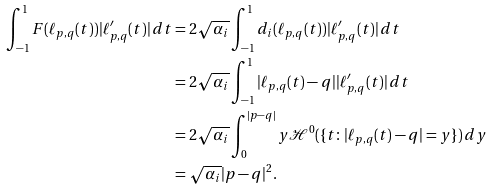Convert formula to latex. <formula><loc_0><loc_0><loc_500><loc_500>\int _ { - 1 } ^ { 1 } F ( \ell _ { p , q } ( t ) ) | \ell _ { p , q } ^ { \prime } ( t ) | \, d t & = 2 \sqrt { \alpha _ { i } } \int _ { - 1 } ^ { 1 } d _ { i } ( \ell _ { p , q } ( t ) ) | \ell _ { p , q } ^ { \prime } ( t ) | \, d t \\ & = 2 \sqrt { \alpha _ { i } } \int _ { - 1 } ^ { 1 } | \ell _ { p , q } ( t ) - q | | \ell _ { p , q } ^ { \prime } ( t ) | \, d t \\ & = 2 \sqrt { \alpha _ { i } } \int _ { 0 } ^ { | p - q | } y \mathcal { H } ^ { 0 } ( \{ t \colon | \ell _ { p , q } ( t ) - q | = y \} ) \, d y \\ & = \sqrt { \alpha _ { i } } | p - q | ^ { 2 } .</formula> 